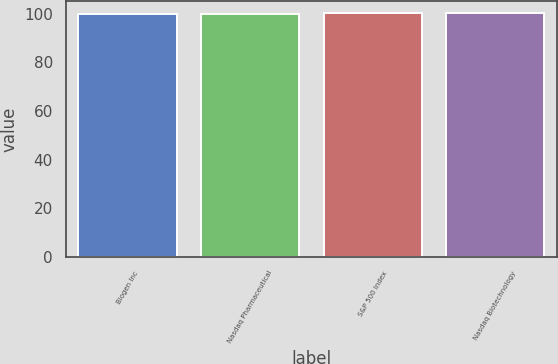Convert chart. <chart><loc_0><loc_0><loc_500><loc_500><bar_chart><fcel>Biogen Inc<fcel>Nasdaq Pharmaceutical<fcel>S&P 500 Index<fcel>Nasdaq Biotechnology<nl><fcel>100<fcel>100.1<fcel>100.2<fcel>100.3<nl></chart> 